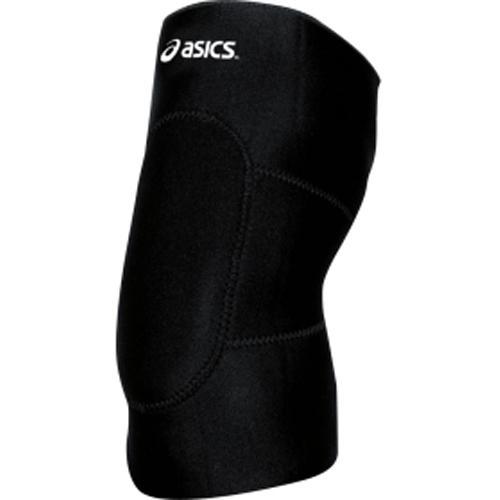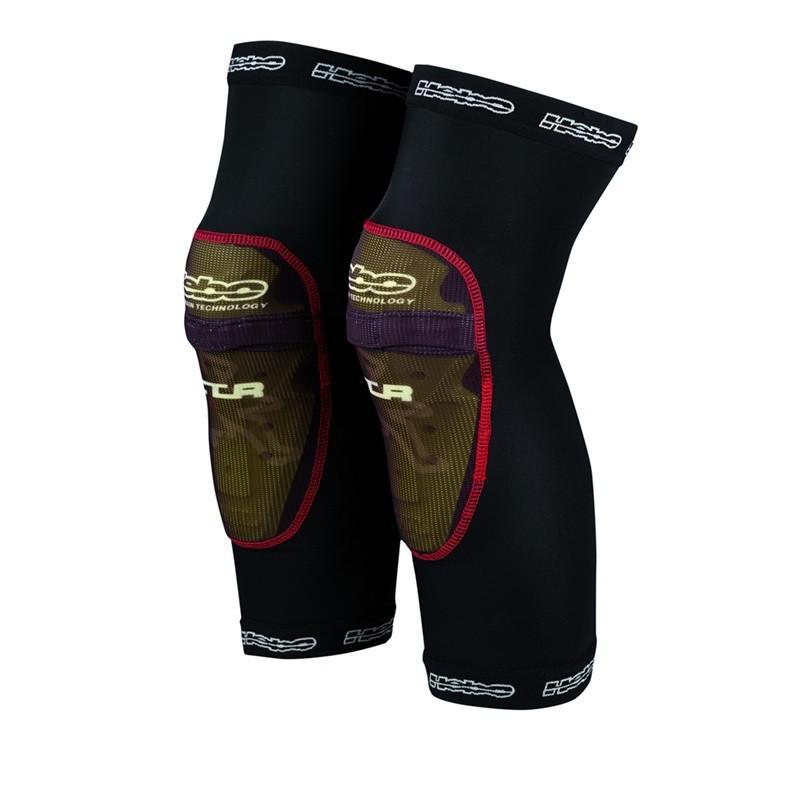The first image is the image on the left, the second image is the image on the right. Assess this claim about the two images: "The only colors on the knee pads are black and white.". Correct or not? Answer yes or no. No. The first image is the image on the left, the second image is the image on the right. Considering the images on both sides, is "The pads are facing left in both images." valid? Answer yes or no. Yes. 